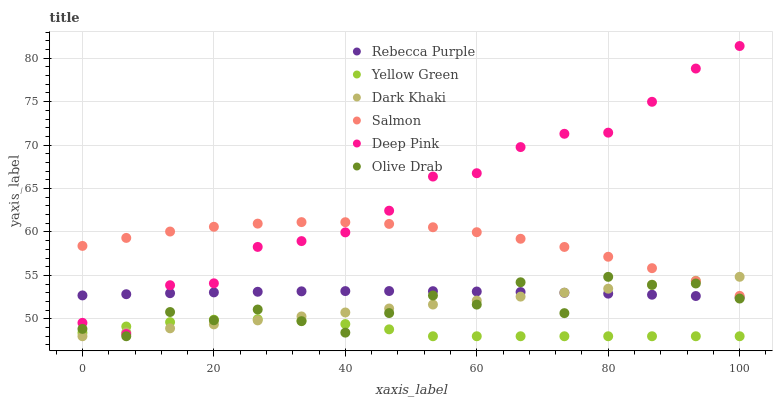Does Yellow Green have the minimum area under the curve?
Answer yes or no. Yes. Does Deep Pink have the maximum area under the curve?
Answer yes or no. Yes. Does Salmon have the minimum area under the curve?
Answer yes or no. No. Does Salmon have the maximum area under the curve?
Answer yes or no. No. Is Dark Khaki the smoothest?
Answer yes or no. Yes. Is Olive Drab the roughest?
Answer yes or no. Yes. Is Yellow Green the smoothest?
Answer yes or no. No. Is Yellow Green the roughest?
Answer yes or no. No. Does Yellow Green have the lowest value?
Answer yes or no. Yes. Does Salmon have the lowest value?
Answer yes or no. No. Does Deep Pink have the highest value?
Answer yes or no. Yes. Does Salmon have the highest value?
Answer yes or no. No. Is Olive Drab less than Deep Pink?
Answer yes or no. Yes. Is Salmon greater than Yellow Green?
Answer yes or no. Yes. Does Deep Pink intersect Yellow Green?
Answer yes or no. Yes. Is Deep Pink less than Yellow Green?
Answer yes or no. No. Is Deep Pink greater than Yellow Green?
Answer yes or no. No. Does Olive Drab intersect Deep Pink?
Answer yes or no. No. 